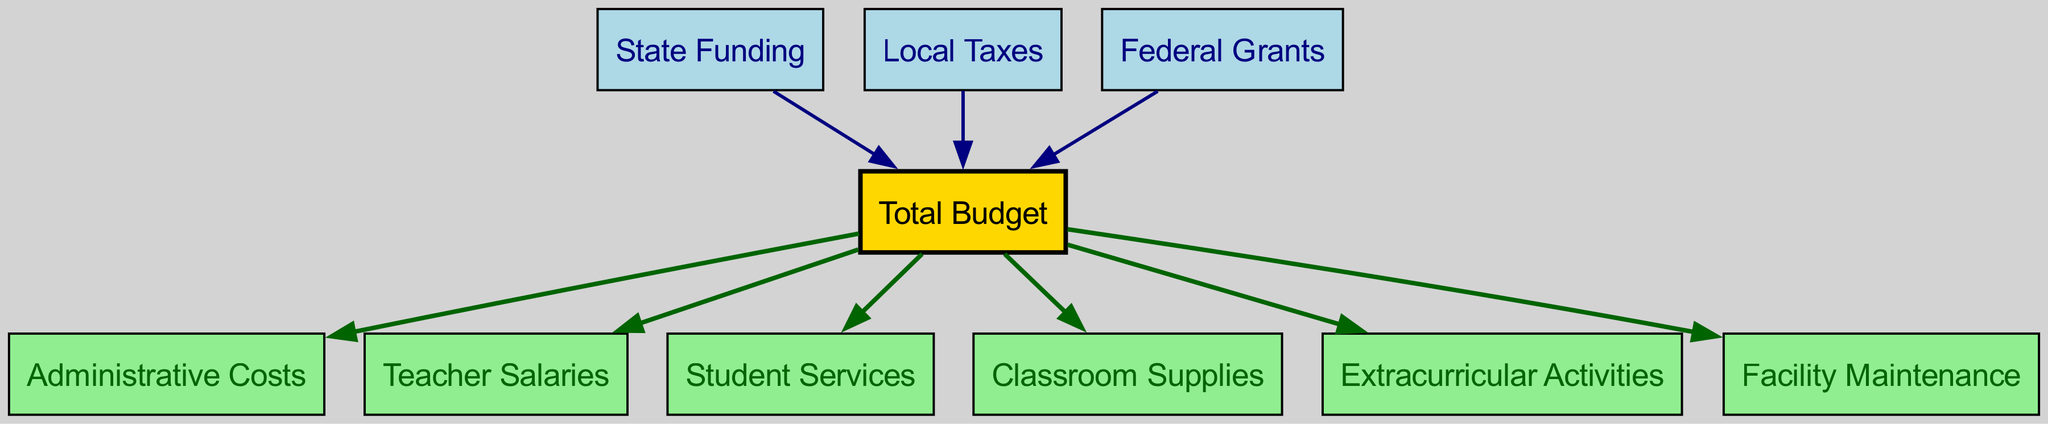What are the three sources of funding represented in the diagram? The diagram shows three sources of funding connected to the Total Budget: State Funding, Local Taxes, and Federal Grants.
Answer: State Funding, Local Taxes, Federal Grants How many nodes are present in the diagram? By counting all the unique nodes listed, there are 10 nodes in total.
Answer: 10 What is the main node that receives all the incoming funding? The Total Budget node receives all incoming edges from the funding sources.
Answer: Total Budget Which two nodes are directly connected to the Total Budget node? The Total Budget node connects directly to Administrative Costs and Teacher Salaries, indicating these are funded from the Total Budget.
Answer: Administrative Costs, Teacher Salaries What color represents the Total Budget node in the diagram? The Total Budget node is depicted in gold, distinguishing it from the other nodes.
Answer: Gold What flows out from the Total Budget node? The edges from the Total Budget indicate that funds flow towards Administrative Costs, Teacher Salaries, Student Services, Classroom Supplies, Extracurricular Activities, and Facility Maintenance.
Answer: Administrative Costs, Teacher Salaries, Student Services, Classroom Supplies, Extracurricular Activities, Facility Maintenance How many edges originate from the Total Budget node? Observing the diagram, there are 6 edges that originate from the Total Budget node, each leading to a different spending category.
Answer: 6 Which funding source contributes to the Total Budget and is shown in light blue? Both State Funding and Local Taxes are represented in light blue and contribute to the Total Budget.
Answer: State Funding, Local Taxes What type of budget item is Facility Maintenance categorized as? Facility Maintenance is categorized as one of the expenditures that flows out from the Total Budget, indicating its typical operational cost.
Answer: Expenditure 